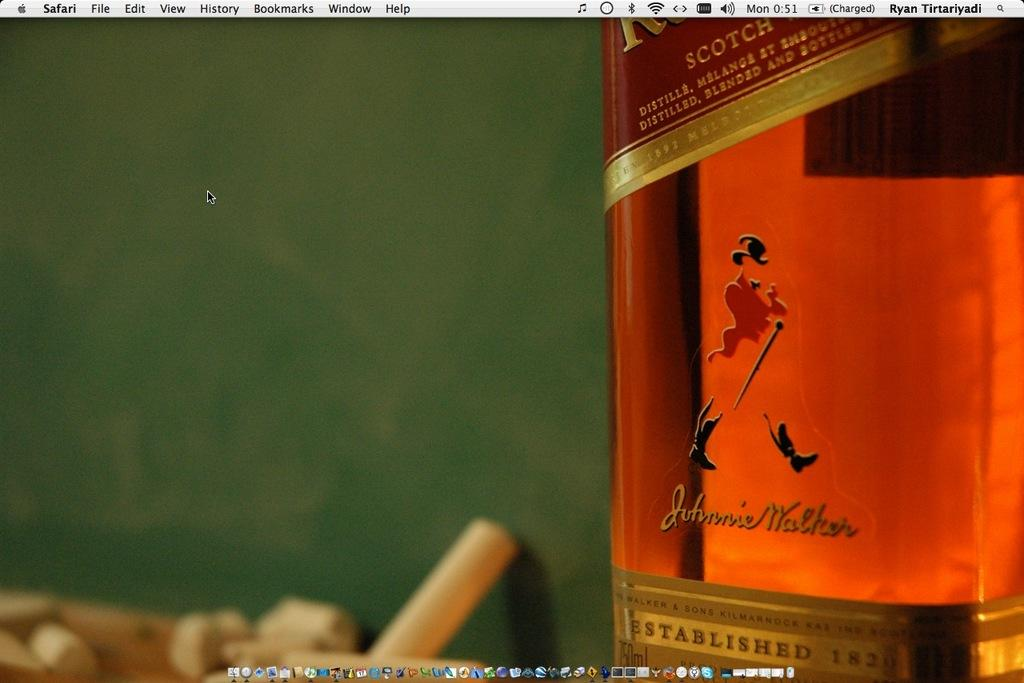<image>
Provide a brief description of the given image. A Macintosh desktop has a bottle of Guthrie Walker Scotch for the wallpaper. 